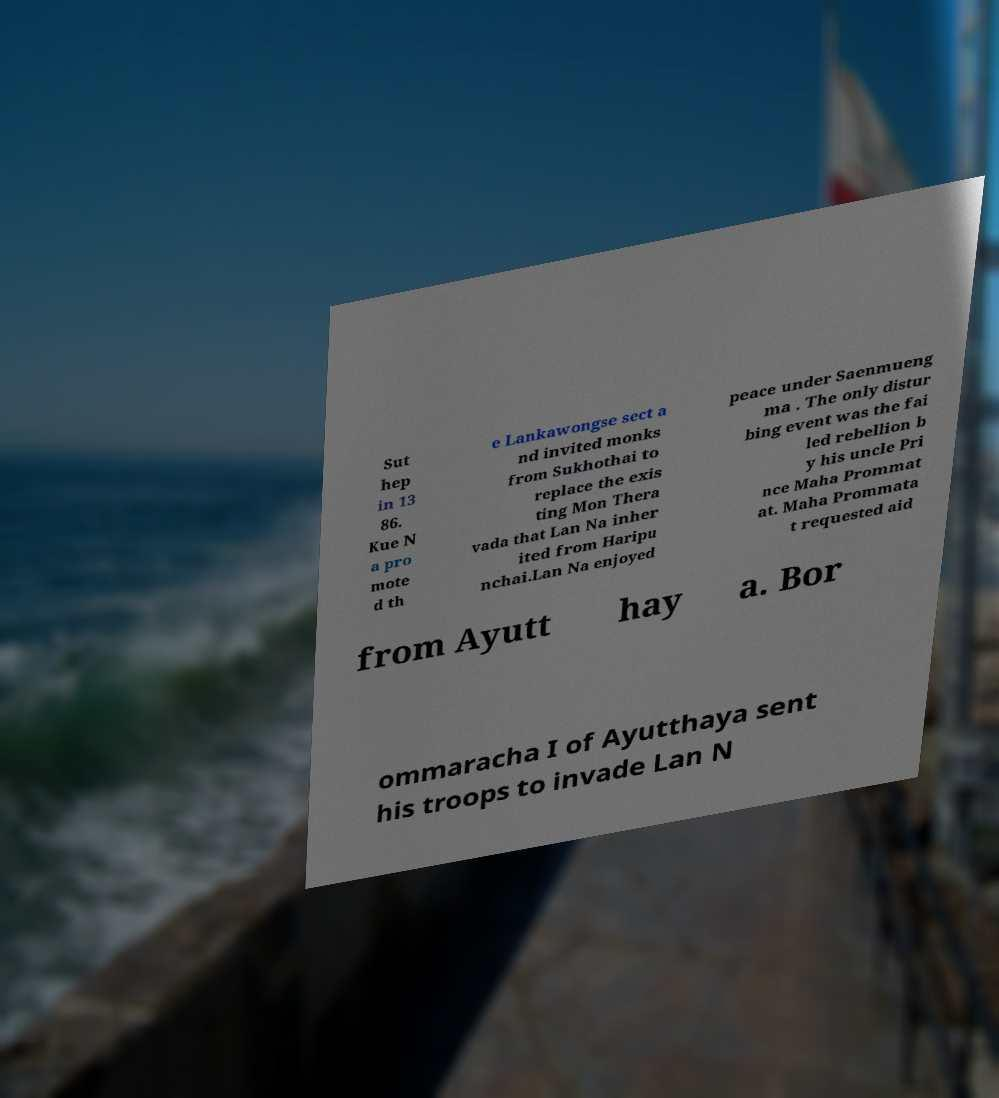Please identify and transcribe the text found in this image. Sut hep in 13 86. Kue N a pro mote d th e Lankawongse sect a nd invited monks from Sukhothai to replace the exis ting Mon Thera vada that Lan Na inher ited from Haripu nchai.Lan Na enjoyed peace under Saenmueng ma . The only distur bing event was the fai led rebellion b y his uncle Pri nce Maha Prommat at. Maha Prommata t requested aid from Ayutt hay a. Bor ommaracha I of Ayutthaya sent his troops to invade Lan N 